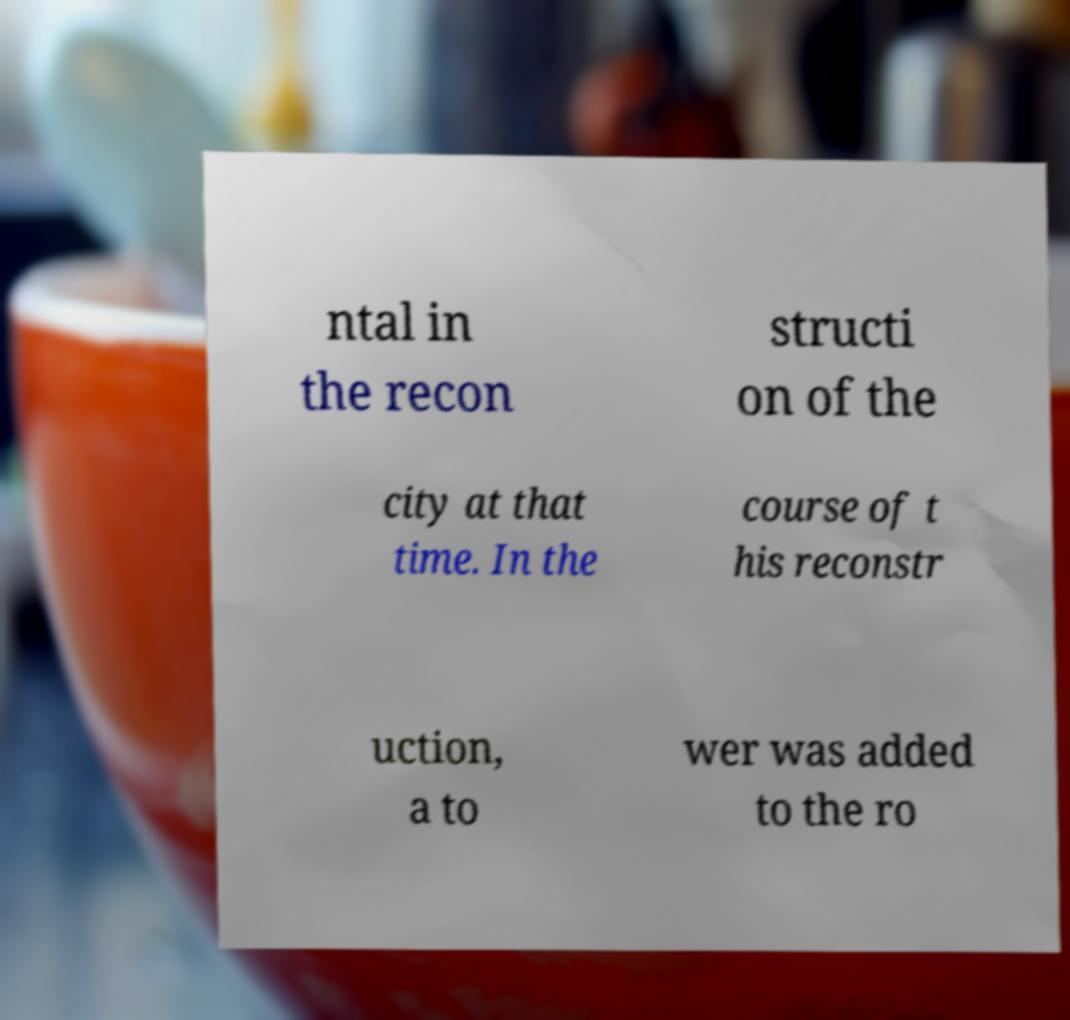Can you accurately transcribe the text from the provided image for me? ntal in the recon structi on of the city at that time. In the course of t his reconstr uction, a to wer was added to the ro 